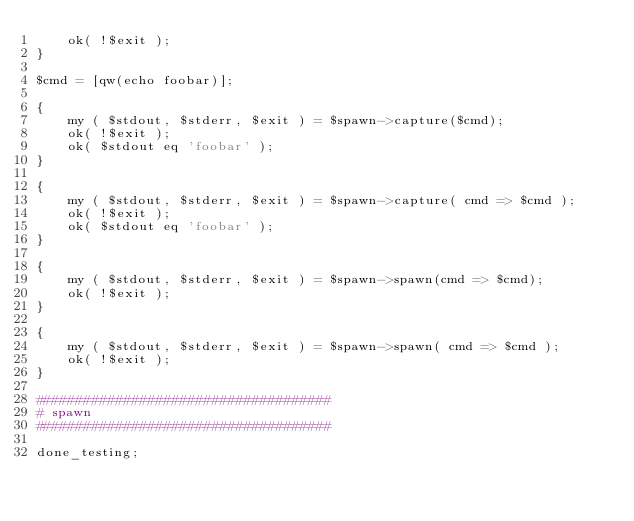<code> <loc_0><loc_0><loc_500><loc_500><_Perl_>	ok( !$exit );
}

$cmd = [qw(echo foobar)];

{
	my ( $stdout, $stderr, $exit ) = $spawn->capture($cmd);
	ok( !$exit );
	ok( $stdout eq 'foobar' );
}

{
	my ( $stdout, $stderr, $exit ) = $spawn->capture( cmd => $cmd );
	ok( !$exit );
	ok( $stdout eq 'foobar' );
}

{
	my ( $stdout, $stderr, $exit ) = $spawn->spawn(cmd => $cmd);
	ok( !$exit );
}

{
	my ( $stdout, $stderr, $exit ) = $spawn->spawn( cmd => $cmd );
	ok( !$exit );
}

#####################################
# spawn
#####################################

done_testing;
</code> 